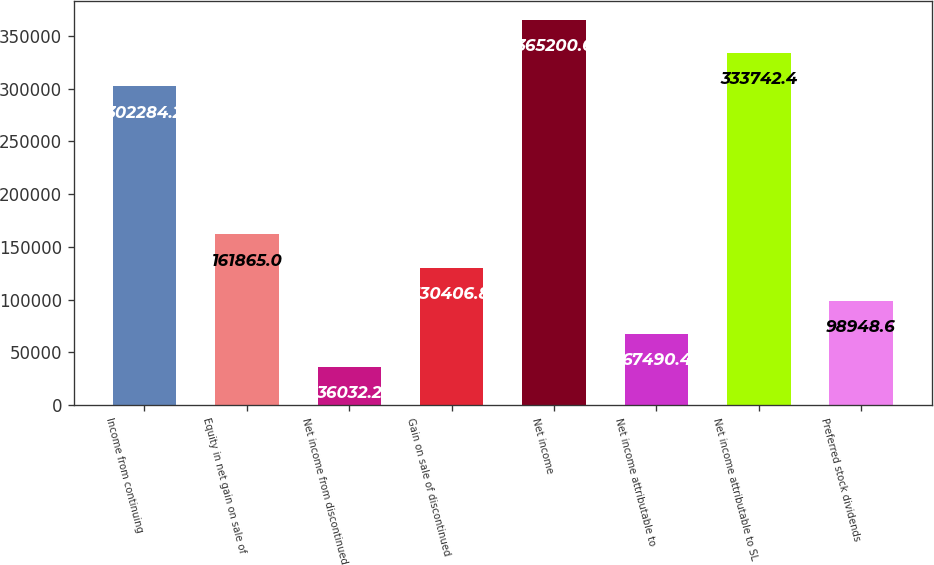Convert chart to OTSL. <chart><loc_0><loc_0><loc_500><loc_500><bar_chart><fcel>Income from continuing<fcel>Equity in net gain on sale of<fcel>Net income from discontinued<fcel>Gain on sale of discontinued<fcel>Net income<fcel>Net income attributable to<fcel>Net income attributable to SL<fcel>Preferred stock dividends<nl><fcel>302284<fcel>161865<fcel>36032.2<fcel>130407<fcel>365201<fcel>67490.4<fcel>333742<fcel>98948.6<nl></chart> 